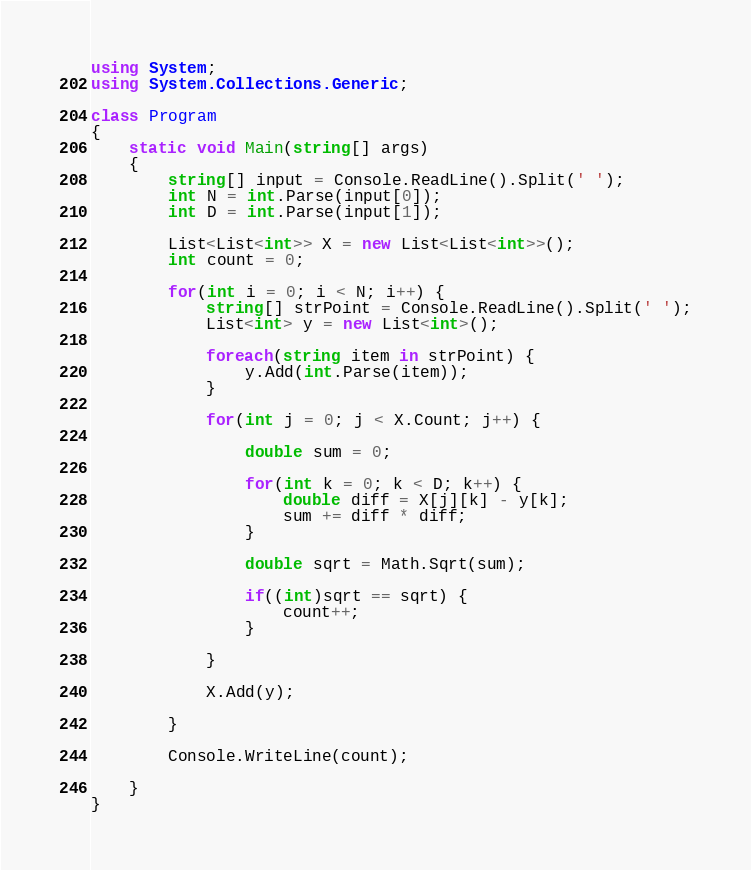<code> <loc_0><loc_0><loc_500><loc_500><_C#_>using System;
using System.Collections.Generic;

class Program
{
    static void Main(string[] args)
    {
        string[] input = Console.ReadLine().Split(' ');
        int N = int.Parse(input[0]);
        int D = int.Parse(input[1]);

        List<List<int>> X = new List<List<int>>();
        int count = 0;

        for(int i = 0; i < N; i++) {
            string[] strPoint = Console.ReadLine().Split(' ');
            List<int> y = new List<int>();

            foreach(string item in strPoint) {
                y.Add(int.Parse(item));
            }

            for(int j = 0; j < X.Count; j++) {
                
                double sum = 0;
            
                for(int k = 0; k < D; k++) {
                    double diff = X[j][k] - y[k];
                    sum += diff * diff;
                }

                double sqrt = Math.Sqrt(sum);

                if((int)sqrt == sqrt) {
                    count++;
                }

            }
            
            X.Add(y);

        }

        Console.WriteLine(count);

    }
}</code> 